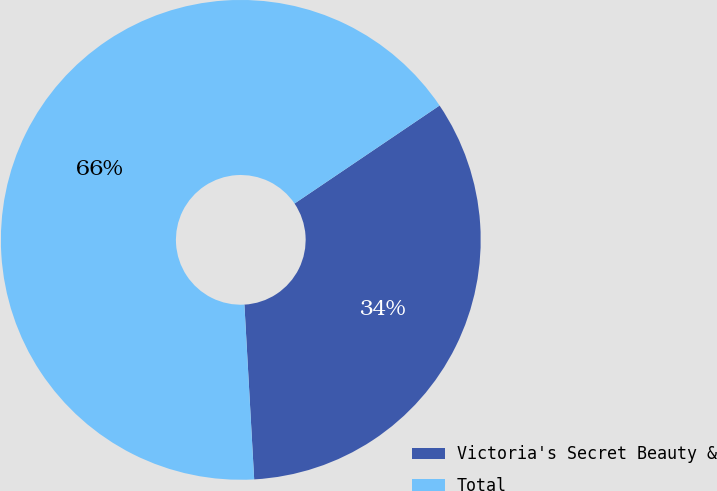Convert chart to OTSL. <chart><loc_0><loc_0><loc_500><loc_500><pie_chart><fcel>Victoria's Secret Beauty &<fcel>Total<nl><fcel>33.57%<fcel>66.43%<nl></chart> 